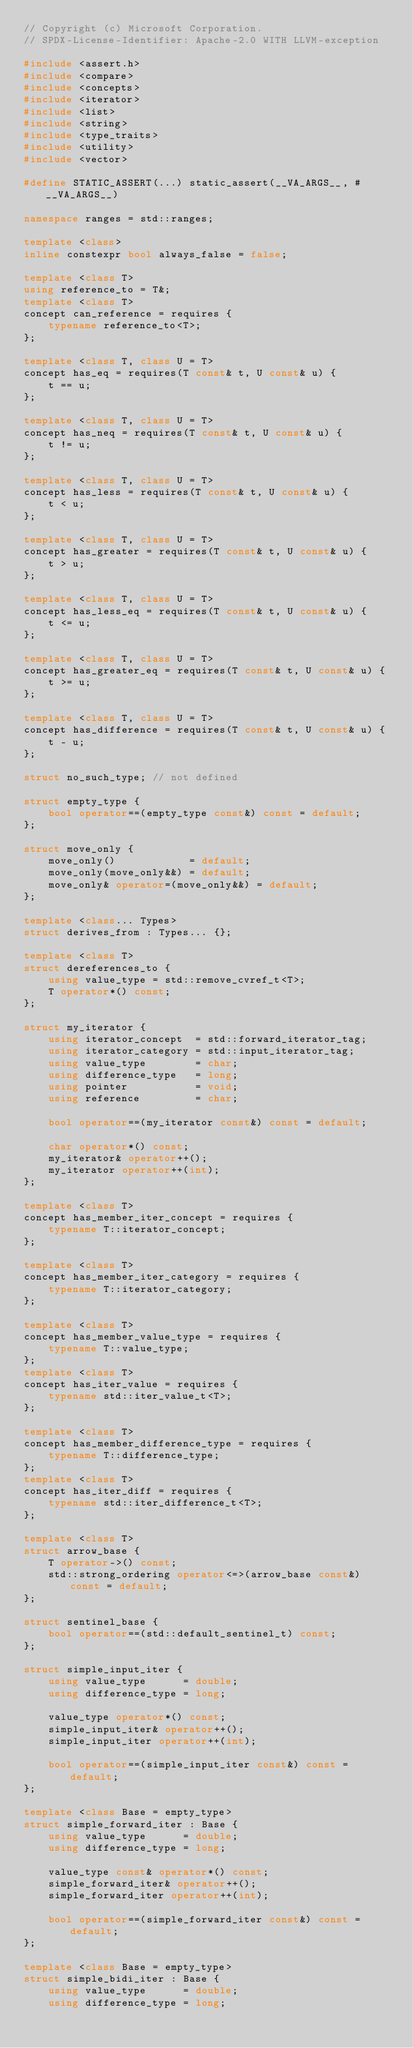<code> <loc_0><loc_0><loc_500><loc_500><_C++_>// Copyright (c) Microsoft Corporation.
// SPDX-License-Identifier: Apache-2.0 WITH LLVM-exception

#include <assert.h>
#include <compare>
#include <concepts>
#include <iterator>
#include <list>
#include <string>
#include <type_traits>
#include <utility>
#include <vector>

#define STATIC_ASSERT(...) static_assert(__VA_ARGS__, #__VA_ARGS__)

namespace ranges = std::ranges;

template <class>
inline constexpr bool always_false = false;

template <class T>
using reference_to = T&;
template <class T>
concept can_reference = requires {
    typename reference_to<T>;
};

template <class T, class U = T>
concept has_eq = requires(T const& t, U const& u) {
    t == u;
};

template <class T, class U = T>
concept has_neq = requires(T const& t, U const& u) {
    t != u;
};

template <class T, class U = T>
concept has_less = requires(T const& t, U const& u) {
    t < u;
};

template <class T, class U = T>
concept has_greater = requires(T const& t, U const& u) {
    t > u;
};

template <class T, class U = T>
concept has_less_eq = requires(T const& t, U const& u) {
    t <= u;
};

template <class T, class U = T>
concept has_greater_eq = requires(T const& t, U const& u) {
    t >= u;
};

template <class T, class U = T>
concept has_difference = requires(T const& t, U const& u) {
    t - u;
};

struct no_such_type; // not defined

struct empty_type {
    bool operator==(empty_type const&) const = default;
};

struct move_only {
    move_only()            = default;
    move_only(move_only&&) = default;
    move_only& operator=(move_only&&) = default;
};

template <class... Types>
struct derives_from : Types... {};

template <class T>
struct dereferences_to {
    using value_type = std::remove_cvref_t<T>;
    T operator*() const;
};

struct my_iterator {
    using iterator_concept  = std::forward_iterator_tag;
    using iterator_category = std::input_iterator_tag;
    using value_type        = char;
    using difference_type   = long;
    using pointer           = void;
    using reference         = char;

    bool operator==(my_iterator const&) const = default;

    char operator*() const;
    my_iterator& operator++();
    my_iterator operator++(int);
};

template <class T>
concept has_member_iter_concept = requires {
    typename T::iterator_concept;
};

template <class T>
concept has_member_iter_category = requires {
    typename T::iterator_category;
};

template <class T>
concept has_member_value_type = requires {
    typename T::value_type;
};
template <class T>
concept has_iter_value = requires {
    typename std::iter_value_t<T>;
};

template <class T>
concept has_member_difference_type = requires {
    typename T::difference_type;
};
template <class T>
concept has_iter_diff = requires {
    typename std::iter_difference_t<T>;
};

template <class T>
struct arrow_base {
    T operator->() const;
    std::strong_ordering operator<=>(arrow_base const&) const = default;
};

struct sentinel_base {
    bool operator==(std::default_sentinel_t) const;
};

struct simple_input_iter {
    using value_type      = double;
    using difference_type = long;

    value_type operator*() const;
    simple_input_iter& operator++();
    simple_input_iter operator++(int);

    bool operator==(simple_input_iter const&) const = default;
};

template <class Base = empty_type>
struct simple_forward_iter : Base {
    using value_type      = double;
    using difference_type = long;

    value_type const& operator*() const;
    simple_forward_iter& operator++();
    simple_forward_iter operator++(int);

    bool operator==(simple_forward_iter const&) const = default;
};

template <class Base = empty_type>
struct simple_bidi_iter : Base {
    using value_type      = double;
    using difference_type = long;</code> 